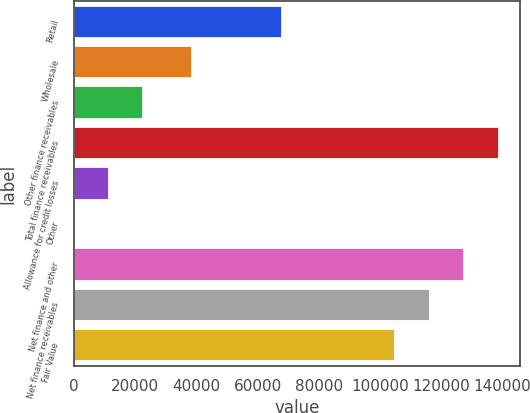Convert chart to OTSL. <chart><loc_0><loc_0><loc_500><loc_500><bar_chart><fcel>Retail<fcel>Wholesale<fcel>Other finance receivables<fcel>Total finance receivables<fcel>Allowance for credit losses<fcel>Other<fcel>Net finance and other<fcel>Net finance receivables<fcel>Fair Value<nl><fcel>67928<fcel>38522<fcel>22606.8<fcel>138815<fcel>11336.4<fcel>66<fcel>127545<fcel>116274<fcel>105004<nl></chart> 